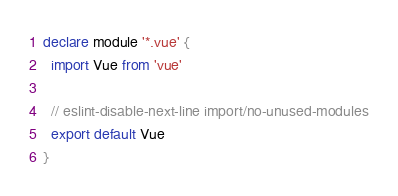Convert code to text. <code><loc_0><loc_0><loc_500><loc_500><_TypeScript_>declare module '*.vue' {
  import Vue from 'vue'

  // eslint-disable-next-line import/no-unused-modules
  export default Vue
}
</code> 